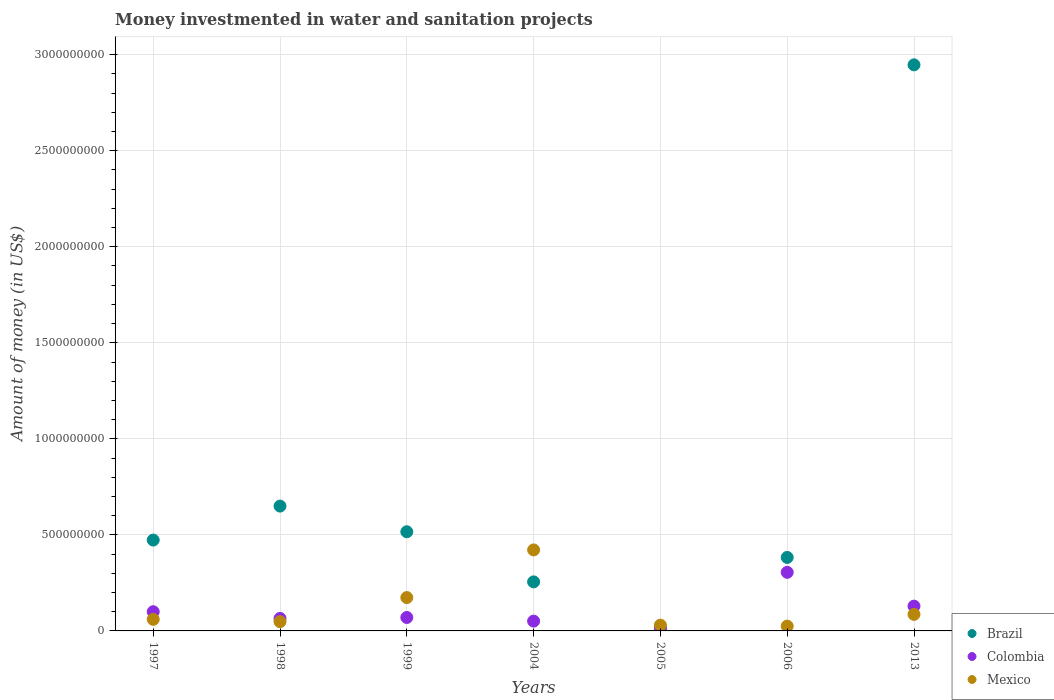Is the number of dotlines equal to the number of legend labels?
Your answer should be very brief. Yes. What is the money investmented in water and sanitation projects in Brazil in 1999?
Keep it short and to the point. 5.16e+08. Across all years, what is the maximum money investmented in water and sanitation projects in Colombia?
Your response must be concise. 3.05e+08. Across all years, what is the minimum money investmented in water and sanitation projects in Colombia?
Offer a very short reply. 1.53e+07. In which year was the money investmented in water and sanitation projects in Brazil minimum?
Give a very brief answer. 2005. What is the total money investmented in water and sanitation projects in Mexico in the graph?
Your answer should be compact. 8.45e+08. What is the difference between the money investmented in water and sanitation projects in Brazil in 1997 and that in 2006?
Your answer should be compact. 9.04e+07. What is the difference between the money investmented in water and sanitation projects in Mexico in 2006 and the money investmented in water and sanitation projects in Colombia in 1999?
Make the answer very short. -4.50e+07. What is the average money investmented in water and sanitation projects in Brazil per year?
Your answer should be very brief. 7.47e+08. In the year 2005, what is the difference between the money investmented in water and sanitation projects in Brazil and money investmented in water and sanitation projects in Colombia?
Make the answer very short. -1.21e+07. What is the ratio of the money investmented in water and sanitation projects in Brazil in 2004 to that in 2013?
Your answer should be compact. 0.09. Is the money investmented in water and sanitation projects in Mexico in 1998 less than that in 2004?
Provide a short and direct response. Yes. What is the difference between the highest and the second highest money investmented in water and sanitation projects in Brazil?
Provide a short and direct response. 2.30e+09. What is the difference between the highest and the lowest money investmented in water and sanitation projects in Colombia?
Give a very brief answer. 2.90e+08. Is the sum of the money investmented in water and sanitation projects in Mexico in 2004 and 2005 greater than the maximum money investmented in water and sanitation projects in Colombia across all years?
Ensure brevity in your answer.  Yes. Does the money investmented in water and sanitation projects in Colombia monotonically increase over the years?
Your answer should be very brief. No. Is the money investmented in water and sanitation projects in Mexico strictly greater than the money investmented in water and sanitation projects in Colombia over the years?
Keep it short and to the point. No. How many dotlines are there?
Provide a short and direct response. 3. What is the difference between two consecutive major ticks on the Y-axis?
Offer a terse response. 5.00e+08. Are the values on the major ticks of Y-axis written in scientific E-notation?
Make the answer very short. No. Does the graph contain grids?
Provide a succinct answer. Yes. How are the legend labels stacked?
Your answer should be compact. Vertical. What is the title of the graph?
Provide a short and direct response. Money investmented in water and sanitation projects. What is the label or title of the X-axis?
Your answer should be compact. Years. What is the label or title of the Y-axis?
Your answer should be very brief. Amount of money (in US$). What is the Amount of money (in US$) in Brazil in 1997?
Provide a short and direct response. 4.73e+08. What is the Amount of money (in US$) of Mexico in 1997?
Provide a short and direct response. 6.02e+07. What is the Amount of money (in US$) of Brazil in 1998?
Your answer should be very brief. 6.50e+08. What is the Amount of money (in US$) in Colombia in 1998?
Provide a succinct answer. 6.50e+07. What is the Amount of money (in US$) of Mexico in 1998?
Provide a succinct answer. 4.82e+07. What is the Amount of money (in US$) of Brazil in 1999?
Your answer should be very brief. 5.16e+08. What is the Amount of money (in US$) in Colombia in 1999?
Your response must be concise. 7.00e+07. What is the Amount of money (in US$) in Mexico in 1999?
Provide a succinct answer. 1.74e+08. What is the Amount of money (in US$) of Brazil in 2004?
Offer a very short reply. 2.55e+08. What is the Amount of money (in US$) in Colombia in 2004?
Offer a terse response. 5.10e+07. What is the Amount of money (in US$) in Mexico in 2004?
Provide a succinct answer. 4.22e+08. What is the Amount of money (in US$) of Brazil in 2005?
Your answer should be compact. 3.16e+06. What is the Amount of money (in US$) in Colombia in 2005?
Offer a very short reply. 1.53e+07. What is the Amount of money (in US$) of Mexico in 2005?
Your answer should be very brief. 3.00e+07. What is the Amount of money (in US$) of Brazil in 2006?
Offer a very short reply. 3.83e+08. What is the Amount of money (in US$) in Colombia in 2006?
Provide a short and direct response. 3.05e+08. What is the Amount of money (in US$) of Mexico in 2006?
Your response must be concise. 2.50e+07. What is the Amount of money (in US$) in Brazil in 2013?
Your answer should be compact. 2.95e+09. What is the Amount of money (in US$) in Colombia in 2013?
Your answer should be compact. 1.29e+08. What is the Amount of money (in US$) in Mexico in 2013?
Your answer should be very brief. 8.62e+07. Across all years, what is the maximum Amount of money (in US$) in Brazil?
Make the answer very short. 2.95e+09. Across all years, what is the maximum Amount of money (in US$) in Colombia?
Offer a very short reply. 3.05e+08. Across all years, what is the maximum Amount of money (in US$) in Mexico?
Your response must be concise. 4.22e+08. Across all years, what is the minimum Amount of money (in US$) of Brazil?
Your answer should be compact. 3.16e+06. Across all years, what is the minimum Amount of money (in US$) in Colombia?
Keep it short and to the point. 1.53e+07. Across all years, what is the minimum Amount of money (in US$) in Mexico?
Offer a very short reply. 2.50e+07. What is the total Amount of money (in US$) of Brazil in the graph?
Provide a short and direct response. 5.23e+09. What is the total Amount of money (in US$) of Colombia in the graph?
Make the answer very short. 7.35e+08. What is the total Amount of money (in US$) in Mexico in the graph?
Your answer should be very brief. 8.45e+08. What is the difference between the Amount of money (in US$) in Brazil in 1997 and that in 1998?
Your response must be concise. -1.77e+08. What is the difference between the Amount of money (in US$) in Colombia in 1997 and that in 1998?
Make the answer very short. 3.50e+07. What is the difference between the Amount of money (in US$) in Brazil in 1997 and that in 1999?
Keep it short and to the point. -4.33e+07. What is the difference between the Amount of money (in US$) in Colombia in 1997 and that in 1999?
Your answer should be very brief. 3.00e+07. What is the difference between the Amount of money (in US$) in Mexico in 1997 and that in 1999?
Give a very brief answer. -1.13e+08. What is the difference between the Amount of money (in US$) of Brazil in 1997 and that in 2004?
Your response must be concise. 2.18e+08. What is the difference between the Amount of money (in US$) of Colombia in 1997 and that in 2004?
Offer a very short reply. 4.90e+07. What is the difference between the Amount of money (in US$) of Mexico in 1997 and that in 2004?
Your response must be concise. -3.62e+08. What is the difference between the Amount of money (in US$) in Brazil in 1997 and that in 2005?
Offer a terse response. 4.70e+08. What is the difference between the Amount of money (in US$) in Colombia in 1997 and that in 2005?
Your answer should be very brief. 8.47e+07. What is the difference between the Amount of money (in US$) of Mexico in 1997 and that in 2005?
Your answer should be very brief. 3.02e+07. What is the difference between the Amount of money (in US$) in Brazil in 1997 and that in 2006?
Provide a short and direct response. 9.04e+07. What is the difference between the Amount of money (in US$) of Colombia in 1997 and that in 2006?
Give a very brief answer. -2.05e+08. What is the difference between the Amount of money (in US$) of Mexico in 1997 and that in 2006?
Make the answer very short. 3.52e+07. What is the difference between the Amount of money (in US$) in Brazil in 1997 and that in 2013?
Your response must be concise. -2.47e+09. What is the difference between the Amount of money (in US$) in Colombia in 1997 and that in 2013?
Ensure brevity in your answer.  -2.90e+07. What is the difference between the Amount of money (in US$) in Mexico in 1997 and that in 2013?
Provide a succinct answer. -2.60e+07. What is the difference between the Amount of money (in US$) of Brazil in 1998 and that in 1999?
Your response must be concise. 1.34e+08. What is the difference between the Amount of money (in US$) of Colombia in 1998 and that in 1999?
Make the answer very short. -5.00e+06. What is the difference between the Amount of money (in US$) of Mexico in 1998 and that in 1999?
Give a very brief answer. -1.25e+08. What is the difference between the Amount of money (in US$) in Brazil in 1998 and that in 2004?
Make the answer very short. 3.95e+08. What is the difference between the Amount of money (in US$) in Colombia in 1998 and that in 2004?
Your answer should be compact. 1.40e+07. What is the difference between the Amount of money (in US$) in Mexico in 1998 and that in 2004?
Ensure brevity in your answer.  -3.74e+08. What is the difference between the Amount of money (in US$) in Brazil in 1998 and that in 2005?
Make the answer very short. 6.47e+08. What is the difference between the Amount of money (in US$) of Colombia in 1998 and that in 2005?
Make the answer very short. 4.97e+07. What is the difference between the Amount of money (in US$) in Mexico in 1998 and that in 2005?
Your answer should be very brief. 1.82e+07. What is the difference between the Amount of money (in US$) of Brazil in 1998 and that in 2006?
Your answer should be compact. 2.67e+08. What is the difference between the Amount of money (in US$) in Colombia in 1998 and that in 2006?
Keep it short and to the point. -2.40e+08. What is the difference between the Amount of money (in US$) in Mexico in 1998 and that in 2006?
Offer a terse response. 2.32e+07. What is the difference between the Amount of money (in US$) of Brazil in 1998 and that in 2013?
Offer a terse response. -2.30e+09. What is the difference between the Amount of money (in US$) in Colombia in 1998 and that in 2013?
Your answer should be compact. -6.40e+07. What is the difference between the Amount of money (in US$) of Mexico in 1998 and that in 2013?
Make the answer very short. -3.80e+07. What is the difference between the Amount of money (in US$) of Brazil in 1999 and that in 2004?
Keep it short and to the point. 2.61e+08. What is the difference between the Amount of money (in US$) in Colombia in 1999 and that in 2004?
Your answer should be compact. 1.90e+07. What is the difference between the Amount of money (in US$) in Mexico in 1999 and that in 2004?
Offer a terse response. -2.48e+08. What is the difference between the Amount of money (in US$) in Brazil in 1999 and that in 2005?
Offer a terse response. 5.13e+08. What is the difference between the Amount of money (in US$) in Colombia in 1999 and that in 2005?
Your answer should be compact. 5.47e+07. What is the difference between the Amount of money (in US$) of Mexico in 1999 and that in 2005?
Keep it short and to the point. 1.44e+08. What is the difference between the Amount of money (in US$) of Brazil in 1999 and that in 2006?
Offer a very short reply. 1.34e+08. What is the difference between the Amount of money (in US$) in Colombia in 1999 and that in 2006?
Offer a terse response. -2.35e+08. What is the difference between the Amount of money (in US$) in Mexico in 1999 and that in 2006?
Provide a succinct answer. 1.49e+08. What is the difference between the Amount of money (in US$) of Brazil in 1999 and that in 2013?
Ensure brevity in your answer.  -2.43e+09. What is the difference between the Amount of money (in US$) of Colombia in 1999 and that in 2013?
Keep it short and to the point. -5.90e+07. What is the difference between the Amount of money (in US$) in Mexico in 1999 and that in 2013?
Provide a short and direct response. 8.74e+07. What is the difference between the Amount of money (in US$) of Brazil in 2004 and that in 2005?
Your response must be concise. 2.52e+08. What is the difference between the Amount of money (in US$) of Colombia in 2004 and that in 2005?
Offer a very short reply. 3.57e+07. What is the difference between the Amount of money (in US$) of Mexico in 2004 and that in 2005?
Your response must be concise. 3.92e+08. What is the difference between the Amount of money (in US$) in Brazil in 2004 and that in 2006?
Give a very brief answer. -1.27e+08. What is the difference between the Amount of money (in US$) in Colombia in 2004 and that in 2006?
Ensure brevity in your answer.  -2.54e+08. What is the difference between the Amount of money (in US$) of Mexico in 2004 and that in 2006?
Your response must be concise. 3.97e+08. What is the difference between the Amount of money (in US$) of Brazil in 2004 and that in 2013?
Your answer should be very brief. -2.69e+09. What is the difference between the Amount of money (in US$) in Colombia in 2004 and that in 2013?
Give a very brief answer. -7.80e+07. What is the difference between the Amount of money (in US$) of Mexico in 2004 and that in 2013?
Ensure brevity in your answer.  3.36e+08. What is the difference between the Amount of money (in US$) of Brazil in 2005 and that in 2006?
Offer a very short reply. -3.79e+08. What is the difference between the Amount of money (in US$) of Colombia in 2005 and that in 2006?
Give a very brief answer. -2.90e+08. What is the difference between the Amount of money (in US$) in Brazil in 2005 and that in 2013?
Make the answer very short. -2.94e+09. What is the difference between the Amount of money (in US$) in Colombia in 2005 and that in 2013?
Give a very brief answer. -1.14e+08. What is the difference between the Amount of money (in US$) in Mexico in 2005 and that in 2013?
Provide a short and direct response. -5.62e+07. What is the difference between the Amount of money (in US$) in Brazil in 2006 and that in 2013?
Your answer should be very brief. -2.56e+09. What is the difference between the Amount of money (in US$) of Colombia in 2006 and that in 2013?
Keep it short and to the point. 1.76e+08. What is the difference between the Amount of money (in US$) of Mexico in 2006 and that in 2013?
Offer a very short reply. -6.12e+07. What is the difference between the Amount of money (in US$) of Brazil in 1997 and the Amount of money (in US$) of Colombia in 1998?
Your response must be concise. 4.08e+08. What is the difference between the Amount of money (in US$) of Brazil in 1997 and the Amount of money (in US$) of Mexico in 1998?
Your answer should be very brief. 4.25e+08. What is the difference between the Amount of money (in US$) in Colombia in 1997 and the Amount of money (in US$) in Mexico in 1998?
Make the answer very short. 5.18e+07. What is the difference between the Amount of money (in US$) of Brazil in 1997 and the Amount of money (in US$) of Colombia in 1999?
Provide a succinct answer. 4.03e+08. What is the difference between the Amount of money (in US$) in Brazil in 1997 and the Amount of money (in US$) in Mexico in 1999?
Make the answer very short. 2.99e+08. What is the difference between the Amount of money (in US$) of Colombia in 1997 and the Amount of money (in US$) of Mexico in 1999?
Offer a very short reply. -7.36e+07. What is the difference between the Amount of money (in US$) in Brazil in 1997 and the Amount of money (in US$) in Colombia in 2004?
Give a very brief answer. 4.22e+08. What is the difference between the Amount of money (in US$) of Brazil in 1997 and the Amount of money (in US$) of Mexico in 2004?
Give a very brief answer. 5.13e+07. What is the difference between the Amount of money (in US$) of Colombia in 1997 and the Amount of money (in US$) of Mexico in 2004?
Your answer should be compact. -3.22e+08. What is the difference between the Amount of money (in US$) of Brazil in 1997 and the Amount of money (in US$) of Colombia in 2005?
Your answer should be compact. 4.58e+08. What is the difference between the Amount of money (in US$) of Brazil in 1997 and the Amount of money (in US$) of Mexico in 2005?
Your answer should be compact. 4.43e+08. What is the difference between the Amount of money (in US$) of Colombia in 1997 and the Amount of money (in US$) of Mexico in 2005?
Give a very brief answer. 7.00e+07. What is the difference between the Amount of money (in US$) of Brazil in 1997 and the Amount of money (in US$) of Colombia in 2006?
Offer a very short reply. 1.68e+08. What is the difference between the Amount of money (in US$) in Brazil in 1997 and the Amount of money (in US$) in Mexico in 2006?
Your answer should be compact. 4.48e+08. What is the difference between the Amount of money (in US$) of Colombia in 1997 and the Amount of money (in US$) of Mexico in 2006?
Provide a short and direct response. 7.50e+07. What is the difference between the Amount of money (in US$) of Brazil in 1997 and the Amount of money (in US$) of Colombia in 2013?
Provide a short and direct response. 3.44e+08. What is the difference between the Amount of money (in US$) in Brazil in 1997 and the Amount of money (in US$) in Mexico in 2013?
Provide a succinct answer. 3.87e+08. What is the difference between the Amount of money (in US$) in Colombia in 1997 and the Amount of money (in US$) in Mexico in 2013?
Give a very brief answer. 1.38e+07. What is the difference between the Amount of money (in US$) in Brazil in 1998 and the Amount of money (in US$) in Colombia in 1999?
Provide a short and direct response. 5.80e+08. What is the difference between the Amount of money (in US$) in Brazil in 1998 and the Amount of money (in US$) in Mexico in 1999?
Provide a short and direct response. 4.76e+08. What is the difference between the Amount of money (in US$) of Colombia in 1998 and the Amount of money (in US$) of Mexico in 1999?
Give a very brief answer. -1.09e+08. What is the difference between the Amount of money (in US$) of Brazil in 1998 and the Amount of money (in US$) of Colombia in 2004?
Offer a terse response. 5.99e+08. What is the difference between the Amount of money (in US$) in Brazil in 1998 and the Amount of money (in US$) in Mexico in 2004?
Provide a succinct answer. 2.28e+08. What is the difference between the Amount of money (in US$) of Colombia in 1998 and the Amount of money (in US$) of Mexico in 2004?
Your answer should be compact. -3.57e+08. What is the difference between the Amount of money (in US$) of Brazil in 1998 and the Amount of money (in US$) of Colombia in 2005?
Offer a terse response. 6.35e+08. What is the difference between the Amount of money (in US$) in Brazil in 1998 and the Amount of money (in US$) in Mexico in 2005?
Give a very brief answer. 6.20e+08. What is the difference between the Amount of money (in US$) of Colombia in 1998 and the Amount of money (in US$) of Mexico in 2005?
Provide a short and direct response. 3.50e+07. What is the difference between the Amount of money (in US$) of Brazil in 1998 and the Amount of money (in US$) of Colombia in 2006?
Ensure brevity in your answer.  3.45e+08. What is the difference between the Amount of money (in US$) in Brazil in 1998 and the Amount of money (in US$) in Mexico in 2006?
Give a very brief answer. 6.25e+08. What is the difference between the Amount of money (in US$) in Colombia in 1998 and the Amount of money (in US$) in Mexico in 2006?
Offer a very short reply. 4.00e+07. What is the difference between the Amount of money (in US$) of Brazil in 1998 and the Amount of money (in US$) of Colombia in 2013?
Offer a very short reply. 5.21e+08. What is the difference between the Amount of money (in US$) of Brazil in 1998 and the Amount of money (in US$) of Mexico in 2013?
Make the answer very short. 5.64e+08. What is the difference between the Amount of money (in US$) of Colombia in 1998 and the Amount of money (in US$) of Mexico in 2013?
Ensure brevity in your answer.  -2.12e+07. What is the difference between the Amount of money (in US$) of Brazil in 1999 and the Amount of money (in US$) of Colombia in 2004?
Offer a terse response. 4.65e+08. What is the difference between the Amount of money (in US$) in Brazil in 1999 and the Amount of money (in US$) in Mexico in 2004?
Keep it short and to the point. 9.46e+07. What is the difference between the Amount of money (in US$) in Colombia in 1999 and the Amount of money (in US$) in Mexico in 2004?
Make the answer very short. -3.52e+08. What is the difference between the Amount of money (in US$) of Brazil in 1999 and the Amount of money (in US$) of Colombia in 2005?
Offer a very short reply. 5.01e+08. What is the difference between the Amount of money (in US$) of Brazil in 1999 and the Amount of money (in US$) of Mexico in 2005?
Your response must be concise. 4.86e+08. What is the difference between the Amount of money (in US$) in Colombia in 1999 and the Amount of money (in US$) in Mexico in 2005?
Keep it short and to the point. 4.00e+07. What is the difference between the Amount of money (in US$) in Brazil in 1999 and the Amount of money (in US$) in Colombia in 2006?
Make the answer very short. 2.11e+08. What is the difference between the Amount of money (in US$) in Brazil in 1999 and the Amount of money (in US$) in Mexico in 2006?
Provide a succinct answer. 4.91e+08. What is the difference between the Amount of money (in US$) in Colombia in 1999 and the Amount of money (in US$) in Mexico in 2006?
Keep it short and to the point. 4.50e+07. What is the difference between the Amount of money (in US$) of Brazil in 1999 and the Amount of money (in US$) of Colombia in 2013?
Your answer should be very brief. 3.87e+08. What is the difference between the Amount of money (in US$) in Brazil in 1999 and the Amount of money (in US$) in Mexico in 2013?
Your answer should be compact. 4.30e+08. What is the difference between the Amount of money (in US$) in Colombia in 1999 and the Amount of money (in US$) in Mexico in 2013?
Your answer should be very brief. -1.62e+07. What is the difference between the Amount of money (in US$) in Brazil in 2004 and the Amount of money (in US$) in Colombia in 2005?
Your answer should be very brief. 2.40e+08. What is the difference between the Amount of money (in US$) of Brazil in 2004 and the Amount of money (in US$) of Mexico in 2005?
Your answer should be very brief. 2.25e+08. What is the difference between the Amount of money (in US$) in Colombia in 2004 and the Amount of money (in US$) in Mexico in 2005?
Provide a succinct answer. 2.10e+07. What is the difference between the Amount of money (in US$) in Brazil in 2004 and the Amount of money (in US$) in Colombia in 2006?
Your answer should be compact. -4.97e+07. What is the difference between the Amount of money (in US$) in Brazil in 2004 and the Amount of money (in US$) in Mexico in 2006?
Offer a very short reply. 2.30e+08. What is the difference between the Amount of money (in US$) in Colombia in 2004 and the Amount of money (in US$) in Mexico in 2006?
Your answer should be very brief. 2.60e+07. What is the difference between the Amount of money (in US$) in Brazil in 2004 and the Amount of money (in US$) in Colombia in 2013?
Your answer should be very brief. 1.26e+08. What is the difference between the Amount of money (in US$) of Brazil in 2004 and the Amount of money (in US$) of Mexico in 2013?
Your answer should be compact. 1.69e+08. What is the difference between the Amount of money (in US$) in Colombia in 2004 and the Amount of money (in US$) in Mexico in 2013?
Give a very brief answer. -3.52e+07. What is the difference between the Amount of money (in US$) of Brazil in 2005 and the Amount of money (in US$) of Colombia in 2006?
Your answer should be very brief. -3.02e+08. What is the difference between the Amount of money (in US$) of Brazil in 2005 and the Amount of money (in US$) of Mexico in 2006?
Your answer should be compact. -2.18e+07. What is the difference between the Amount of money (in US$) of Colombia in 2005 and the Amount of money (in US$) of Mexico in 2006?
Your answer should be very brief. -9.72e+06. What is the difference between the Amount of money (in US$) in Brazil in 2005 and the Amount of money (in US$) in Colombia in 2013?
Your answer should be compact. -1.26e+08. What is the difference between the Amount of money (in US$) of Brazil in 2005 and the Amount of money (in US$) of Mexico in 2013?
Make the answer very short. -8.30e+07. What is the difference between the Amount of money (in US$) in Colombia in 2005 and the Amount of money (in US$) in Mexico in 2013?
Keep it short and to the point. -7.09e+07. What is the difference between the Amount of money (in US$) of Brazil in 2006 and the Amount of money (in US$) of Colombia in 2013?
Offer a very short reply. 2.54e+08. What is the difference between the Amount of money (in US$) in Brazil in 2006 and the Amount of money (in US$) in Mexico in 2013?
Make the answer very short. 2.96e+08. What is the difference between the Amount of money (in US$) of Colombia in 2006 and the Amount of money (in US$) of Mexico in 2013?
Offer a very short reply. 2.19e+08. What is the average Amount of money (in US$) of Brazil per year?
Your answer should be very brief. 7.47e+08. What is the average Amount of money (in US$) in Colombia per year?
Make the answer very short. 1.05e+08. What is the average Amount of money (in US$) in Mexico per year?
Ensure brevity in your answer.  1.21e+08. In the year 1997, what is the difference between the Amount of money (in US$) in Brazil and Amount of money (in US$) in Colombia?
Offer a terse response. 3.73e+08. In the year 1997, what is the difference between the Amount of money (in US$) of Brazil and Amount of money (in US$) of Mexico?
Offer a terse response. 4.13e+08. In the year 1997, what is the difference between the Amount of money (in US$) in Colombia and Amount of money (in US$) in Mexico?
Give a very brief answer. 3.98e+07. In the year 1998, what is the difference between the Amount of money (in US$) in Brazil and Amount of money (in US$) in Colombia?
Your answer should be compact. 5.85e+08. In the year 1998, what is the difference between the Amount of money (in US$) in Brazil and Amount of money (in US$) in Mexico?
Your response must be concise. 6.02e+08. In the year 1998, what is the difference between the Amount of money (in US$) of Colombia and Amount of money (in US$) of Mexico?
Ensure brevity in your answer.  1.68e+07. In the year 1999, what is the difference between the Amount of money (in US$) in Brazil and Amount of money (in US$) in Colombia?
Provide a succinct answer. 4.46e+08. In the year 1999, what is the difference between the Amount of money (in US$) in Brazil and Amount of money (in US$) in Mexico?
Make the answer very short. 3.43e+08. In the year 1999, what is the difference between the Amount of money (in US$) of Colombia and Amount of money (in US$) of Mexico?
Your response must be concise. -1.04e+08. In the year 2004, what is the difference between the Amount of money (in US$) of Brazil and Amount of money (in US$) of Colombia?
Keep it short and to the point. 2.04e+08. In the year 2004, what is the difference between the Amount of money (in US$) in Brazil and Amount of money (in US$) in Mexico?
Offer a very short reply. -1.66e+08. In the year 2004, what is the difference between the Amount of money (in US$) in Colombia and Amount of money (in US$) in Mexico?
Provide a short and direct response. -3.71e+08. In the year 2005, what is the difference between the Amount of money (in US$) of Brazil and Amount of money (in US$) of Colombia?
Your answer should be compact. -1.21e+07. In the year 2005, what is the difference between the Amount of money (in US$) in Brazil and Amount of money (in US$) in Mexico?
Offer a terse response. -2.68e+07. In the year 2005, what is the difference between the Amount of money (in US$) in Colombia and Amount of money (in US$) in Mexico?
Provide a short and direct response. -1.47e+07. In the year 2006, what is the difference between the Amount of money (in US$) in Brazil and Amount of money (in US$) in Colombia?
Your response must be concise. 7.76e+07. In the year 2006, what is the difference between the Amount of money (in US$) of Brazil and Amount of money (in US$) of Mexico?
Offer a terse response. 3.58e+08. In the year 2006, what is the difference between the Amount of money (in US$) of Colombia and Amount of money (in US$) of Mexico?
Give a very brief answer. 2.80e+08. In the year 2013, what is the difference between the Amount of money (in US$) in Brazil and Amount of money (in US$) in Colombia?
Your response must be concise. 2.82e+09. In the year 2013, what is the difference between the Amount of money (in US$) of Brazil and Amount of money (in US$) of Mexico?
Ensure brevity in your answer.  2.86e+09. In the year 2013, what is the difference between the Amount of money (in US$) of Colombia and Amount of money (in US$) of Mexico?
Your response must be concise. 4.28e+07. What is the ratio of the Amount of money (in US$) in Brazil in 1997 to that in 1998?
Ensure brevity in your answer.  0.73. What is the ratio of the Amount of money (in US$) in Colombia in 1997 to that in 1998?
Ensure brevity in your answer.  1.54. What is the ratio of the Amount of money (in US$) in Mexico in 1997 to that in 1998?
Your answer should be very brief. 1.25. What is the ratio of the Amount of money (in US$) of Brazil in 1997 to that in 1999?
Provide a short and direct response. 0.92. What is the ratio of the Amount of money (in US$) in Colombia in 1997 to that in 1999?
Provide a short and direct response. 1.43. What is the ratio of the Amount of money (in US$) of Mexico in 1997 to that in 1999?
Your answer should be very brief. 0.35. What is the ratio of the Amount of money (in US$) of Brazil in 1997 to that in 2004?
Give a very brief answer. 1.85. What is the ratio of the Amount of money (in US$) in Colombia in 1997 to that in 2004?
Ensure brevity in your answer.  1.96. What is the ratio of the Amount of money (in US$) in Mexico in 1997 to that in 2004?
Your answer should be compact. 0.14. What is the ratio of the Amount of money (in US$) in Brazil in 1997 to that in 2005?
Ensure brevity in your answer.  149.49. What is the ratio of the Amount of money (in US$) in Colombia in 1997 to that in 2005?
Keep it short and to the point. 6.54. What is the ratio of the Amount of money (in US$) of Mexico in 1997 to that in 2005?
Give a very brief answer. 2.01. What is the ratio of the Amount of money (in US$) of Brazil in 1997 to that in 2006?
Your answer should be very brief. 1.24. What is the ratio of the Amount of money (in US$) of Colombia in 1997 to that in 2006?
Provide a succinct answer. 0.33. What is the ratio of the Amount of money (in US$) in Mexico in 1997 to that in 2006?
Provide a short and direct response. 2.41. What is the ratio of the Amount of money (in US$) in Brazil in 1997 to that in 2013?
Your answer should be compact. 0.16. What is the ratio of the Amount of money (in US$) of Colombia in 1997 to that in 2013?
Offer a terse response. 0.78. What is the ratio of the Amount of money (in US$) of Mexico in 1997 to that in 2013?
Keep it short and to the point. 0.7. What is the ratio of the Amount of money (in US$) in Brazil in 1998 to that in 1999?
Keep it short and to the point. 1.26. What is the ratio of the Amount of money (in US$) in Colombia in 1998 to that in 1999?
Provide a succinct answer. 0.93. What is the ratio of the Amount of money (in US$) of Mexico in 1998 to that in 1999?
Provide a succinct answer. 0.28. What is the ratio of the Amount of money (in US$) in Brazil in 1998 to that in 2004?
Give a very brief answer. 2.55. What is the ratio of the Amount of money (in US$) in Colombia in 1998 to that in 2004?
Your answer should be compact. 1.27. What is the ratio of the Amount of money (in US$) of Mexico in 1998 to that in 2004?
Give a very brief answer. 0.11. What is the ratio of the Amount of money (in US$) of Brazil in 1998 to that in 2005?
Offer a very short reply. 205.4. What is the ratio of the Amount of money (in US$) in Colombia in 1998 to that in 2005?
Provide a succinct answer. 4.25. What is the ratio of the Amount of money (in US$) of Mexico in 1998 to that in 2005?
Offer a terse response. 1.61. What is the ratio of the Amount of money (in US$) in Brazil in 1998 to that in 2006?
Your response must be concise. 1.7. What is the ratio of the Amount of money (in US$) in Colombia in 1998 to that in 2006?
Your response must be concise. 0.21. What is the ratio of the Amount of money (in US$) in Mexico in 1998 to that in 2006?
Provide a succinct answer. 1.93. What is the ratio of the Amount of money (in US$) in Brazil in 1998 to that in 2013?
Your answer should be very brief. 0.22. What is the ratio of the Amount of money (in US$) in Colombia in 1998 to that in 2013?
Make the answer very short. 0.5. What is the ratio of the Amount of money (in US$) in Mexico in 1998 to that in 2013?
Your answer should be very brief. 0.56. What is the ratio of the Amount of money (in US$) of Brazil in 1999 to that in 2004?
Your answer should be very brief. 2.02. What is the ratio of the Amount of money (in US$) in Colombia in 1999 to that in 2004?
Your response must be concise. 1.37. What is the ratio of the Amount of money (in US$) in Mexico in 1999 to that in 2004?
Make the answer very short. 0.41. What is the ratio of the Amount of money (in US$) of Brazil in 1999 to that in 2005?
Provide a succinct answer. 163.18. What is the ratio of the Amount of money (in US$) of Colombia in 1999 to that in 2005?
Ensure brevity in your answer.  4.58. What is the ratio of the Amount of money (in US$) in Mexico in 1999 to that in 2005?
Give a very brief answer. 5.79. What is the ratio of the Amount of money (in US$) in Brazil in 1999 to that in 2006?
Offer a very short reply. 1.35. What is the ratio of the Amount of money (in US$) of Colombia in 1999 to that in 2006?
Your answer should be very brief. 0.23. What is the ratio of the Amount of money (in US$) of Mexico in 1999 to that in 2006?
Provide a short and direct response. 6.94. What is the ratio of the Amount of money (in US$) in Brazil in 1999 to that in 2013?
Your answer should be compact. 0.18. What is the ratio of the Amount of money (in US$) of Colombia in 1999 to that in 2013?
Offer a terse response. 0.54. What is the ratio of the Amount of money (in US$) in Mexico in 1999 to that in 2013?
Your answer should be very brief. 2.02. What is the ratio of the Amount of money (in US$) of Brazil in 2004 to that in 2005?
Your response must be concise. 80.7. What is the ratio of the Amount of money (in US$) of Colombia in 2004 to that in 2005?
Ensure brevity in your answer.  3.34. What is the ratio of the Amount of money (in US$) of Mexico in 2004 to that in 2005?
Your answer should be compact. 14.06. What is the ratio of the Amount of money (in US$) in Brazil in 2004 to that in 2006?
Offer a very short reply. 0.67. What is the ratio of the Amount of money (in US$) in Colombia in 2004 to that in 2006?
Offer a terse response. 0.17. What is the ratio of the Amount of money (in US$) of Mexico in 2004 to that in 2006?
Make the answer very short. 16.87. What is the ratio of the Amount of money (in US$) of Brazil in 2004 to that in 2013?
Your answer should be very brief. 0.09. What is the ratio of the Amount of money (in US$) in Colombia in 2004 to that in 2013?
Offer a terse response. 0.4. What is the ratio of the Amount of money (in US$) of Mexico in 2004 to that in 2013?
Offer a terse response. 4.89. What is the ratio of the Amount of money (in US$) in Brazil in 2005 to that in 2006?
Ensure brevity in your answer.  0.01. What is the ratio of the Amount of money (in US$) in Colombia in 2005 to that in 2006?
Your answer should be compact. 0.05. What is the ratio of the Amount of money (in US$) of Mexico in 2005 to that in 2006?
Your response must be concise. 1.2. What is the ratio of the Amount of money (in US$) of Brazil in 2005 to that in 2013?
Ensure brevity in your answer.  0. What is the ratio of the Amount of money (in US$) of Colombia in 2005 to that in 2013?
Your answer should be very brief. 0.12. What is the ratio of the Amount of money (in US$) in Mexico in 2005 to that in 2013?
Make the answer very short. 0.35. What is the ratio of the Amount of money (in US$) in Brazil in 2006 to that in 2013?
Provide a succinct answer. 0.13. What is the ratio of the Amount of money (in US$) in Colombia in 2006 to that in 2013?
Keep it short and to the point. 2.36. What is the ratio of the Amount of money (in US$) in Mexico in 2006 to that in 2013?
Provide a short and direct response. 0.29. What is the difference between the highest and the second highest Amount of money (in US$) in Brazil?
Provide a succinct answer. 2.30e+09. What is the difference between the highest and the second highest Amount of money (in US$) in Colombia?
Ensure brevity in your answer.  1.76e+08. What is the difference between the highest and the second highest Amount of money (in US$) in Mexico?
Your answer should be very brief. 2.48e+08. What is the difference between the highest and the lowest Amount of money (in US$) of Brazil?
Provide a short and direct response. 2.94e+09. What is the difference between the highest and the lowest Amount of money (in US$) of Colombia?
Your response must be concise. 2.90e+08. What is the difference between the highest and the lowest Amount of money (in US$) of Mexico?
Your answer should be very brief. 3.97e+08. 